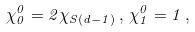<formula> <loc_0><loc_0><loc_500><loc_500>\chi ^ { 0 } _ { 0 } = 2 \chi _ { S ( d - 1 ) } \, , \, \chi ^ { 0 } _ { 1 } = 1 \, ,</formula> 